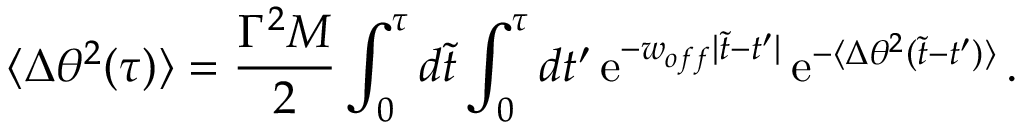Convert formula to latex. <formula><loc_0><loc_0><loc_500><loc_500>\langle \Delta \theta ^ { 2 } ( \tau ) \rangle = { \frac { \Gamma ^ { 2 } M } { 2 } } \int _ { 0 } ^ { \tau } d \tilde { t } \int _ { 0 } ^ { \tau } d t ^ { \prime } \, e ^ { - w _ { o f f } | \tilde { t } - t ^ { \prime } | } \, e ^ { - \langle \Delta \theta ^ { 2 } ( \tilde { t } - t ^ { \prime } ) \rangle } \, .</formula> 